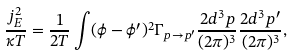Convert formula to latex. <formula><loc_0><loc_0><loc_500><loc_500>\frac { j _ { E } ^ { 2 } } { \kappa T } = \frac { 1 } { 2 T } \int ( \phi - \phi ^ { \prime } ) ^ { 2 } \Gamma _ { p \rightarrow p ^ { \prime } } \frac { 2 d ^ { 3 } p } { ( 2 \pi ) ^ { 3 } } \frac { 2 d ^ { 3 } p ^ { \prime } } { ( 2 \pi ) ^ { 3 } } ,</formula> 